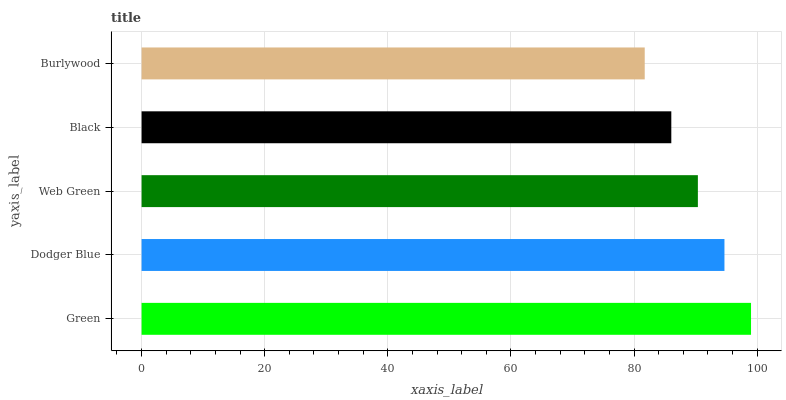Is Burlywood the minimum?
Answer yes or no. Yes. Is Green the maximum?
Answer yes or no. Yes. Is Dodger Blue the minimum?
Answer yes or no. No. Is Dodger Blue the maximum?
Answer yes or no. No. Is Green greater than Dodger Blue?
Answer yes or no. Yes. Is Dodger Blue less than Green?
Answer yes or no. Yes. Is Dodger Blue greater than Green?
Answer yes or no. No. Is Green less than Dodger Blue?
Answer yes or no. No. Is Web Green the high median?
Answer yes or no. Yes. Is Web Green the low median?
Answer yes or no. Yes. Is Green the high median?
Answer yes or no. No. Is Black the low median?
Answer yes or no. No. 